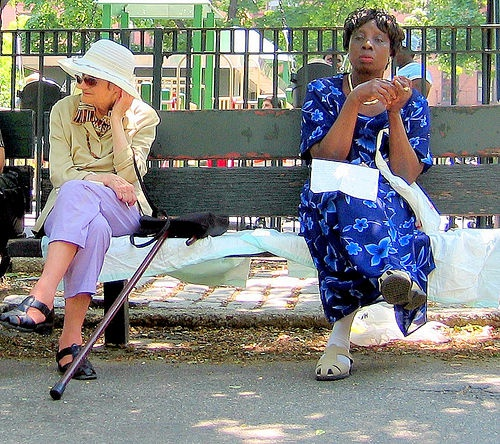Describe the objects in this image and their specific colors. I can see people in black, navy, white, and brown tones, bench in black, gray, purple, and ivory tones, people in black, lightgray, violet, and tan tones, handbag in black, gray, and white tones, and handbag in black, lightgray, darkgray, and lightblue tones in this image. 